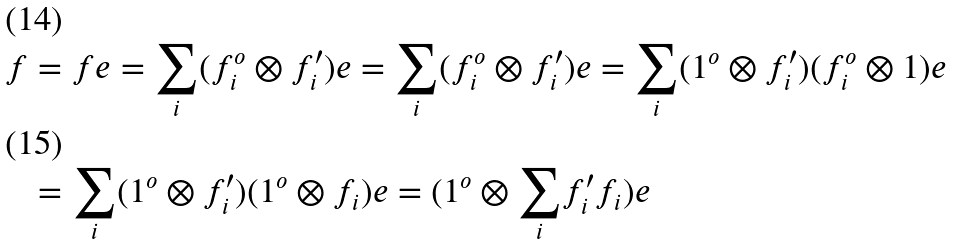<formula> <loc_0><loc_0><loc_500><loc_500>f & = f e = \underset { i } { \sum } ( f ^ { o } _ { i } \otimes f ^ { \prime } _ { i } ) e = \underset { i } { \sum } ( f ^ { o } _ { i } \otimes f ^ { \prime } _ { i } ) e = \underset { i } { \sum } ( 1 ^ { o } \otimes f ^ { \prime } _ { i } ) ( f ^ { o } _ { i } \otimes 1 ) e \\ & = \underset { i } { \sum } ( 1 ^ { o } \otimes f ^ { \prime } _ { i } ) ( 1 ^ { o } \otimes f _ { i } ) e = ( 1 ^ { o } \otimes \underset { i } { \sum } f ^ { \prime } _ { i } f _ { i } ) e</formula> 